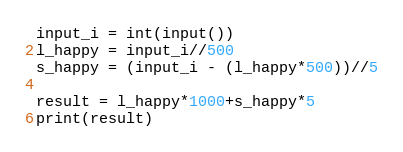Convert code to text. <code><loc_0><loc_0><loc_500><loc_500><_Python_>input_i = int(input())
l_happy = input_i//500
s_happy = (input_i - (l_happy*500))//5

result = l_happy*1000+s_happy*5
print(result)
</code> 